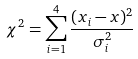Convert formula to latex. <formula><loc_0><loc_0><loc_500><loc_500>\chi ^ { 2 } = \sum _ { i = 1 } ^ { 4 } \frac { ( x _ { i } - x ) ^ { 2 } } { \sigma _ { i } ^ { 2 } }</formula> 